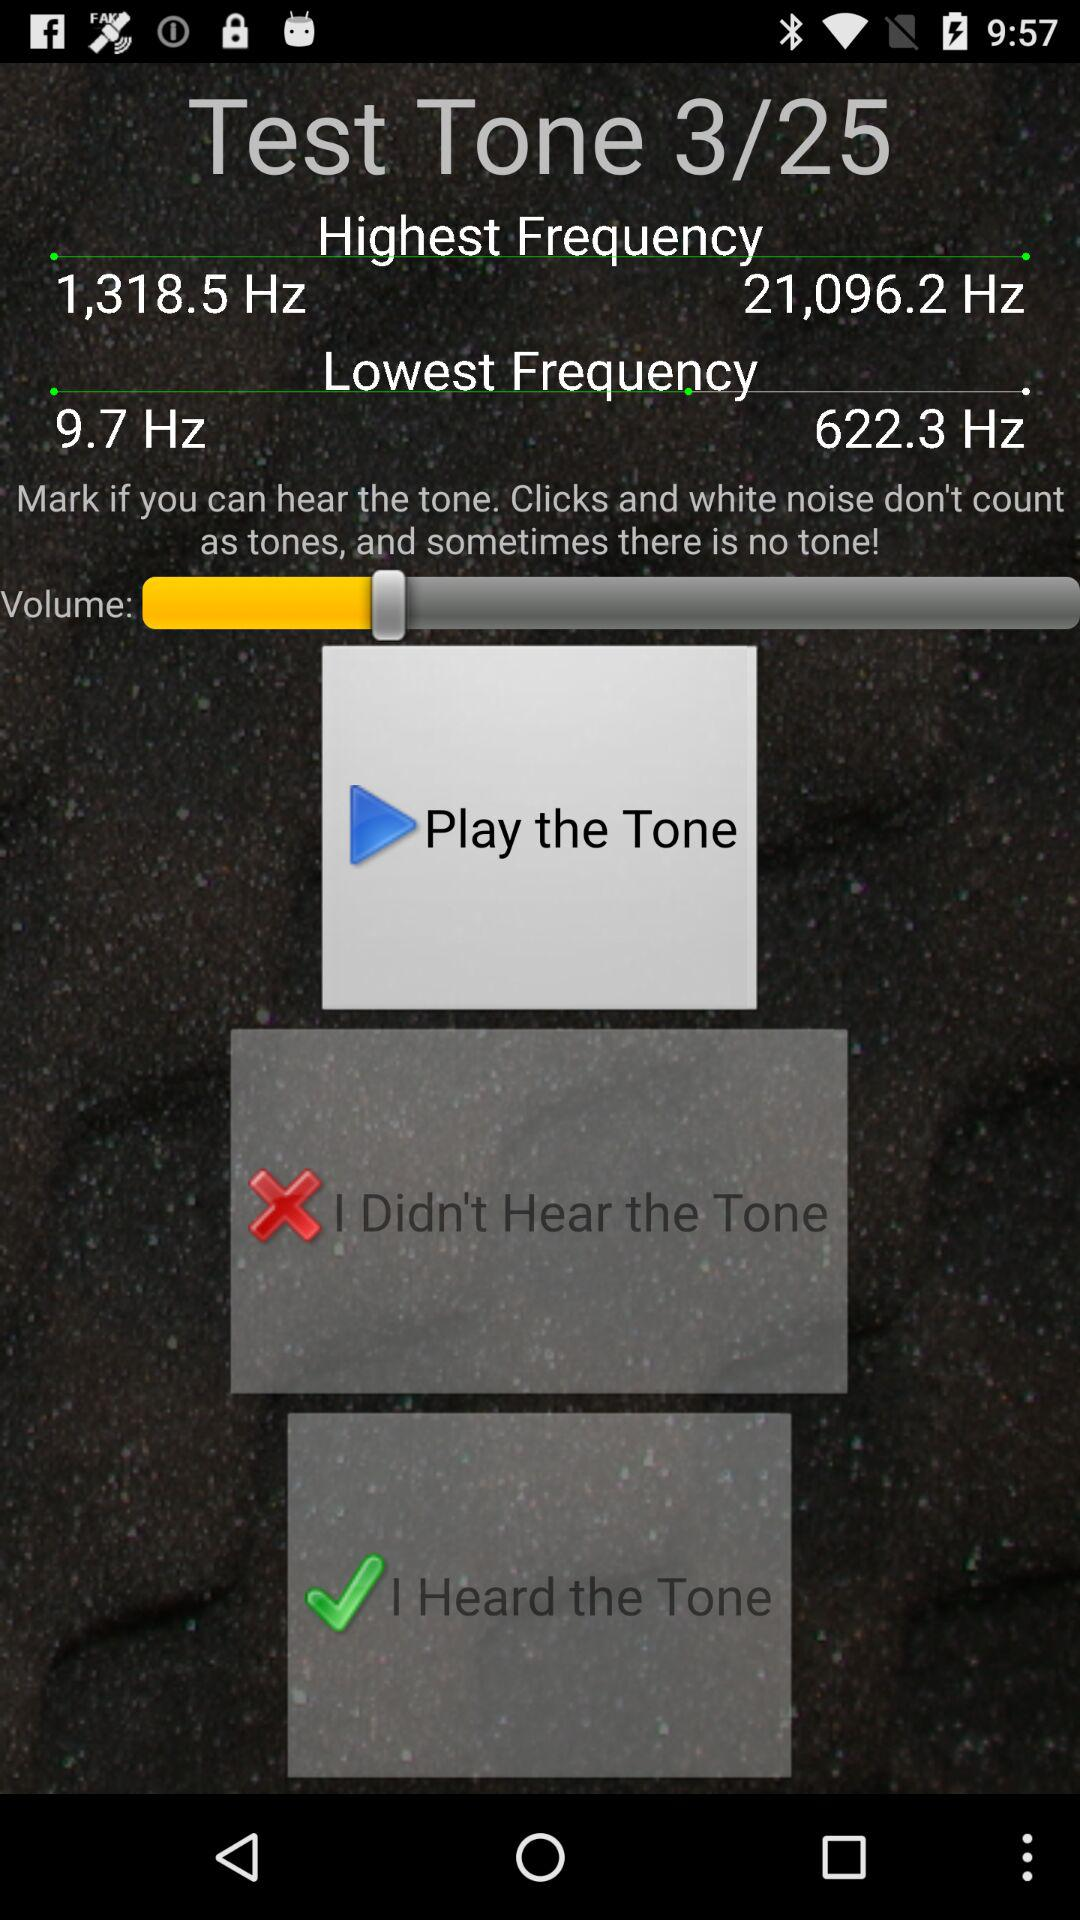How many test tones in total are there? There are 25 test tones. 